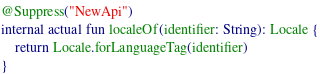<code> <loc_0><loc_0><loc_500><loc_500><_Kotlin_>
@Suppress("NewApi")
internal actual fun localeOf(identifier: String): Locale {
    return Locale.forLanguageTag(identifier)
}</code> 